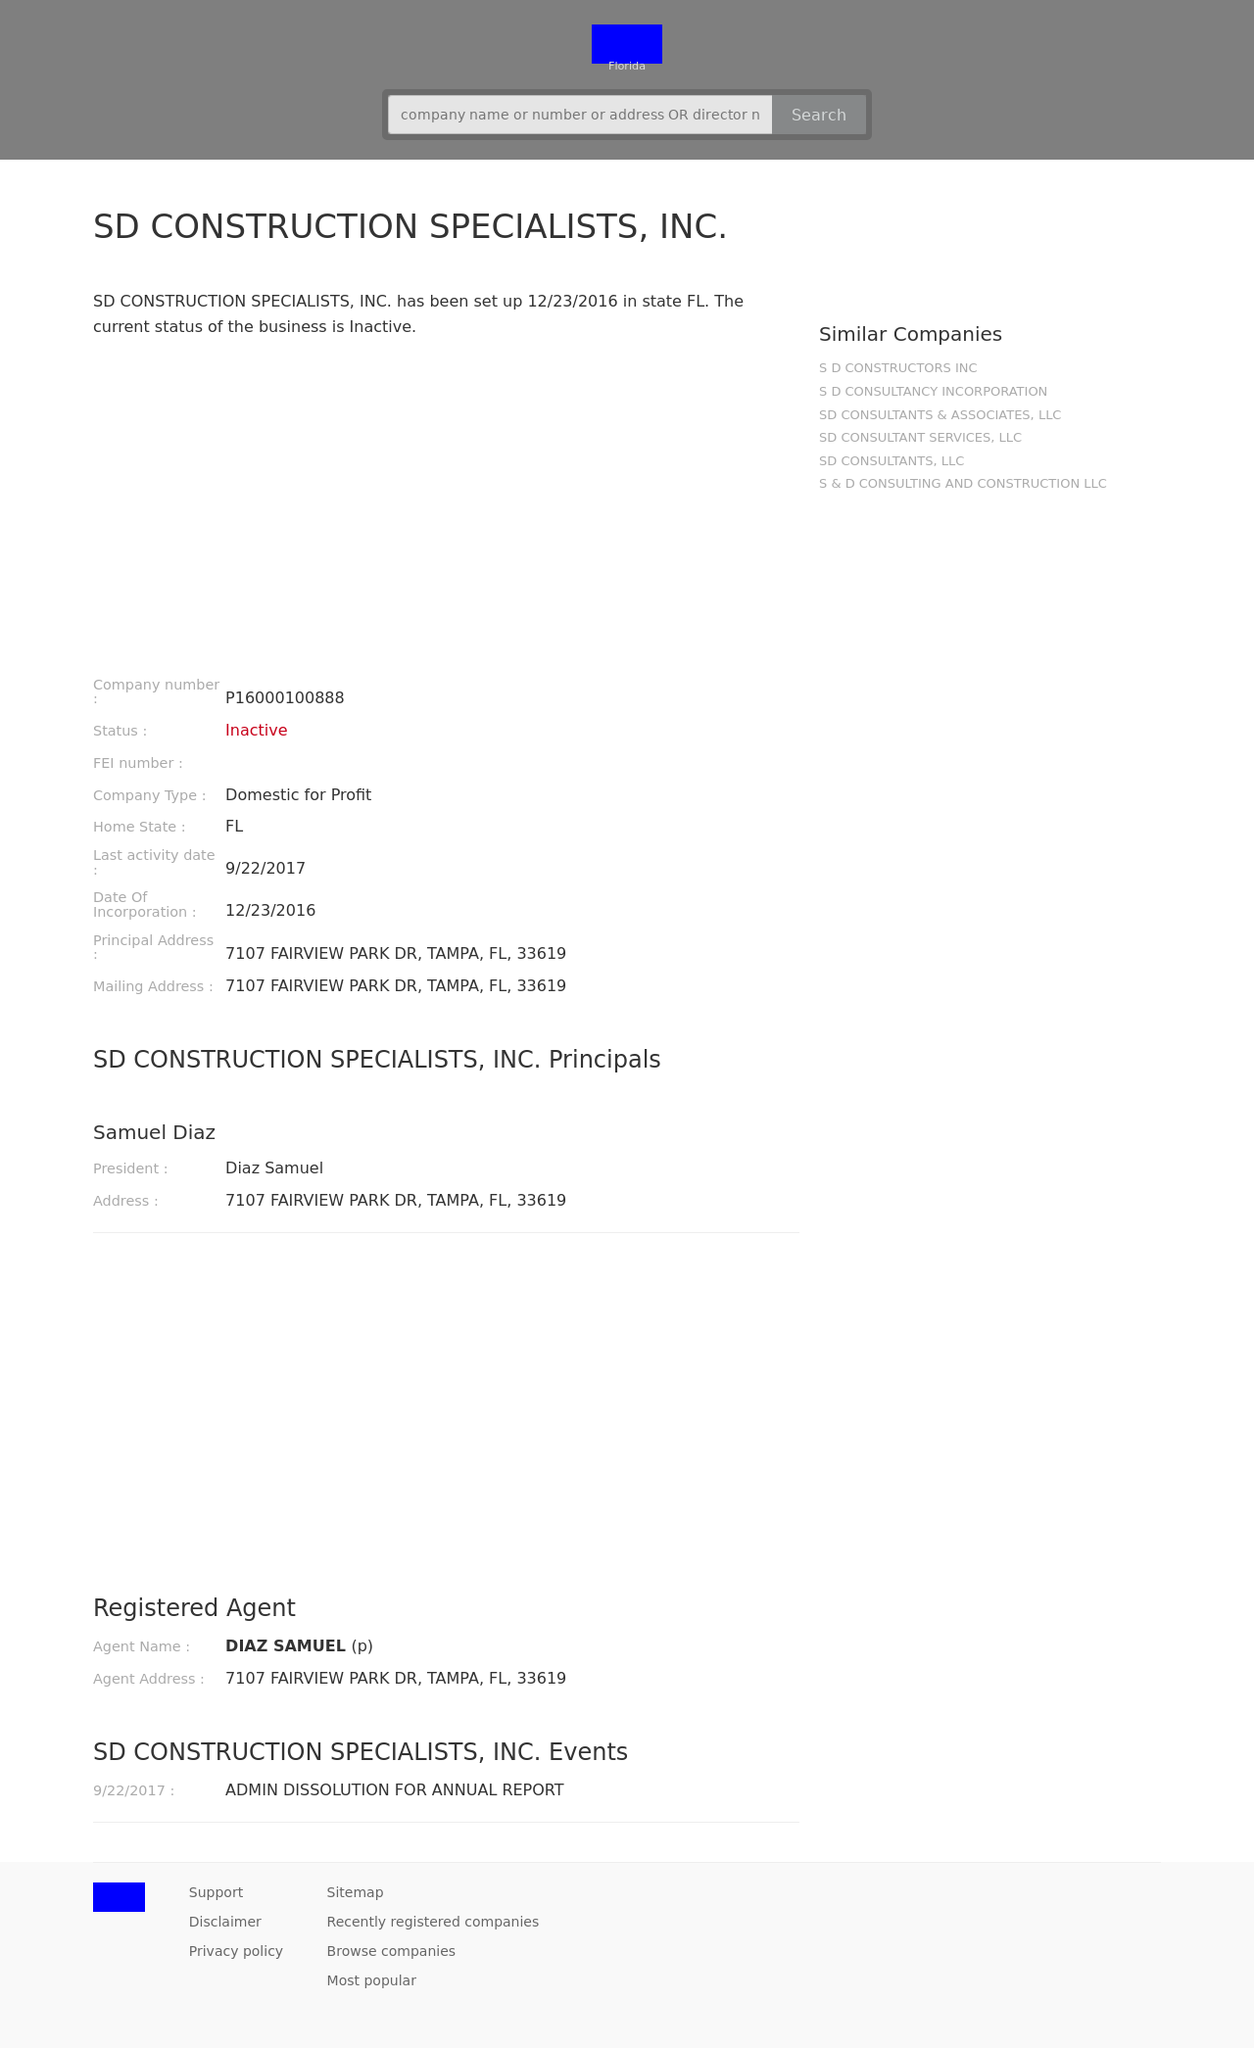What design elements can I incorporate to make the website more visually appealing? To enhance the visual appeal of your website, consider incorporating high-quality images, using a harmonious color palette, and implementing modern fonts that fit your brand. Utilize CSS for custom layouts and transitions to create an engaging user experience. Adding interactive elements such as hover effects, dropdown menus, and modal pop-ups can also significantly improve the overall aesthetics and usability. 